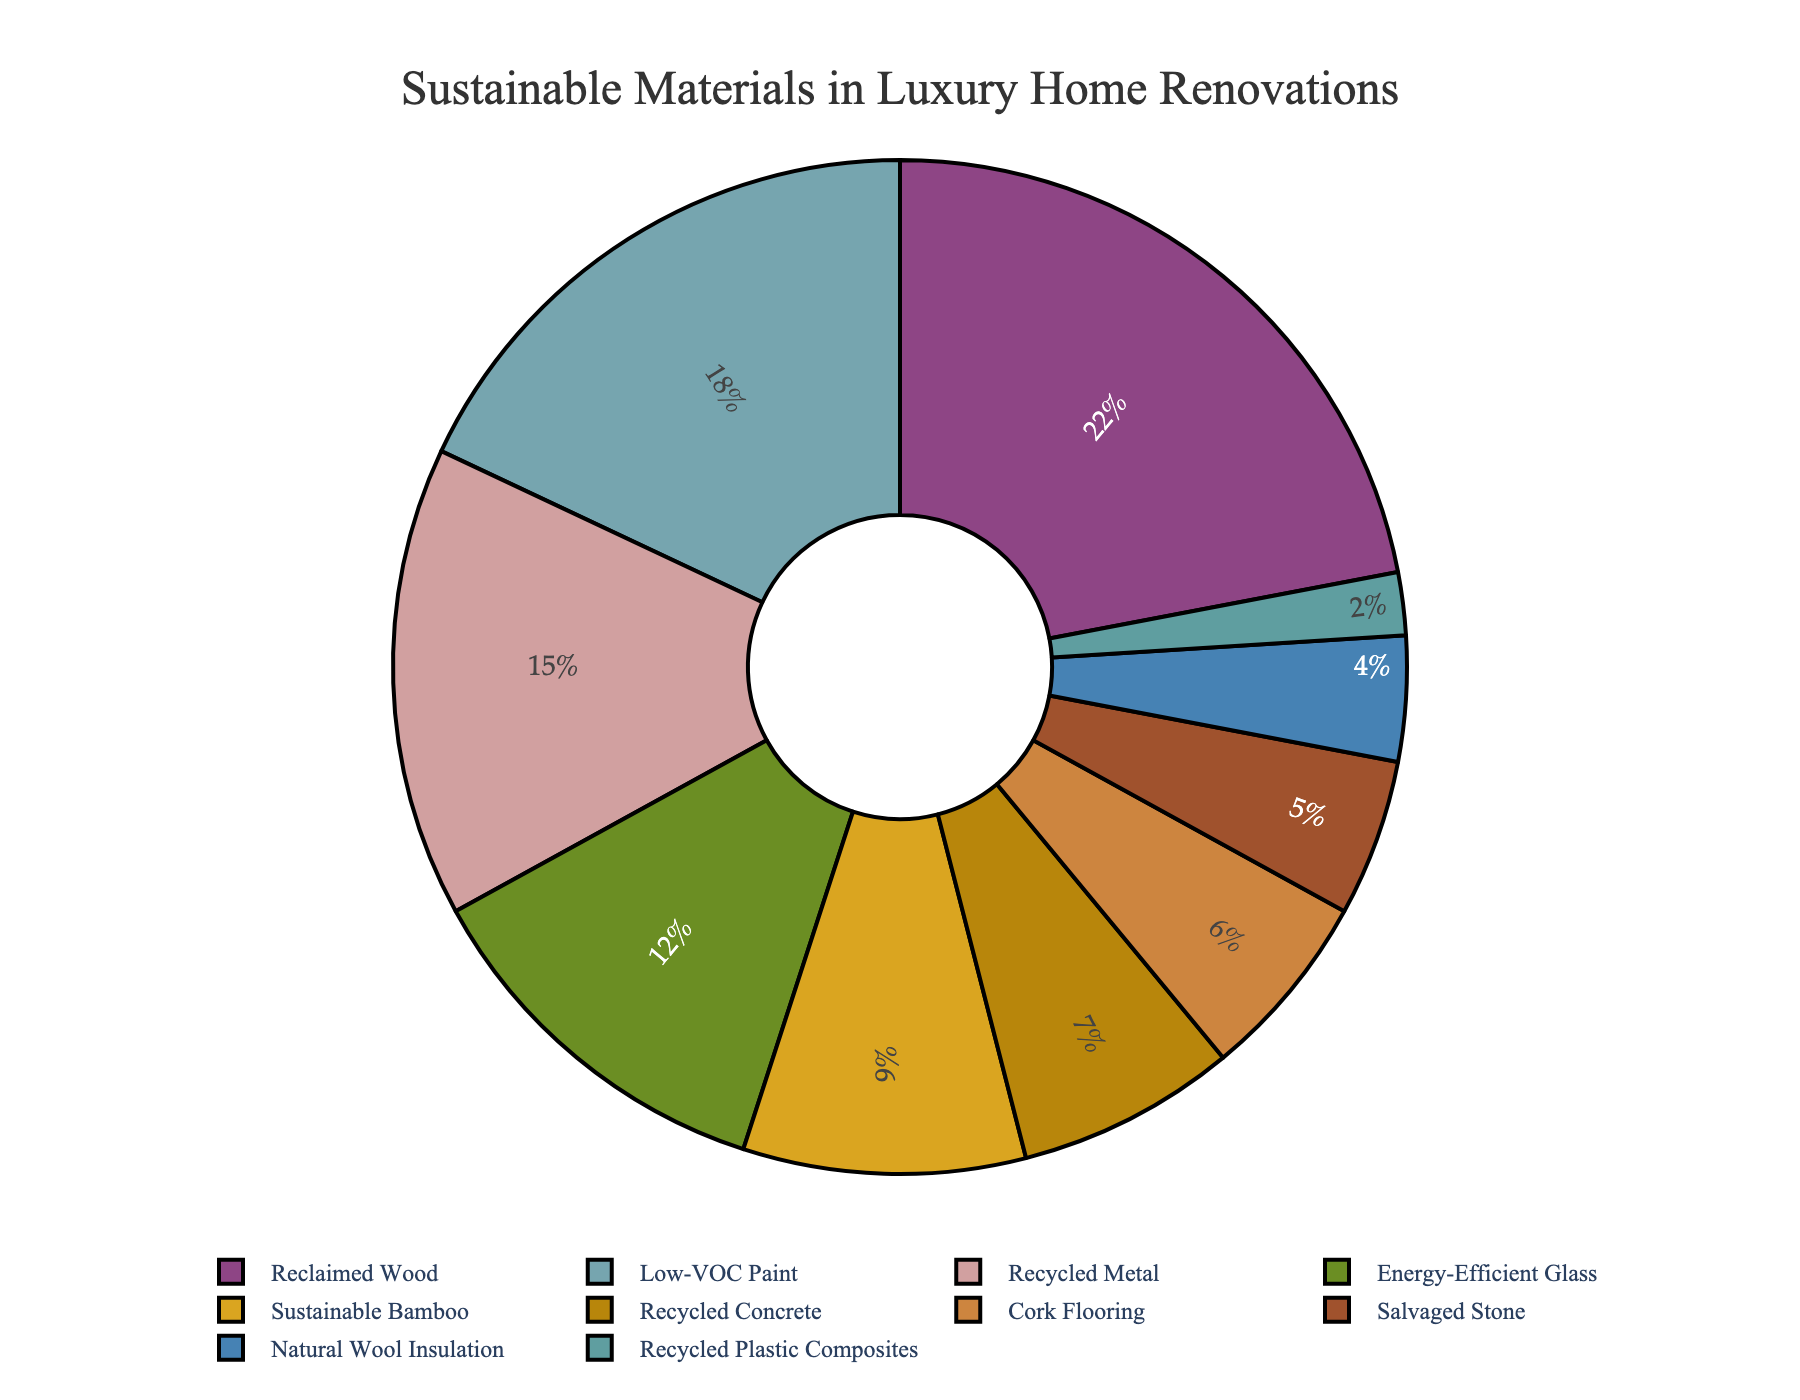What is the largest proportion of sustainable materials used? By looking at the pie chart, we see that the segment for Reclaimed Wood is the largest. It's written as 22%.
Answer: 22% Which material has the smallest proportion? The segment for Recycled Plastic Composites is the smallest, listed as 2%.
Answer: Recycled Plastic Composites What is the combined percentage of Low-VOC Paint and Energy-Efficient Glass? Add the percentages of Low-VOC Paint (18%) and Energy-Efficient Glass (12%), so 18% + 12% = 30%.
Answer: 30% How does the proportion of Recycled Metal compare to Reclaimed Wood? Reclaimed Wood has 22% while Recycled Metal has 15%. Thus, Reclaimed Wood is higher by 22% - 15% = 7%.
Answer: Reclaimed Wood is higher by 7% Which material has a slightly higher percentage than Cork Flooring? Cork Flooring is at 6%, and the next higher percentage is Recycled Concrete at 7%.
Answer: Recycled Concrete What is the difference in percentage between the highest and lowest material proportions? The highest is Reclaimed Wood at 22% and the lowest is Recycled Plastic Composites at 2%. So, 22% - 2% = 20%.
Answer: 20% What percentage of materials used are categorized under metals? Since only Recycled Metal is categorized under metals, it is directly indicated in the pie chart as 15%.
Answer: 15% Which two materials together make up the same percentage as Reclaimed Wood? Reclaimed Wood is 22%. Adding the percentages of Low-VOC Paint (18%) and Recycled Plastic Composites (2%) gives 18% + 2% = 20%, and adding Sustainable Bamboo (9%) and Recycled Concrete (7%) gives 9% + 7% = 16%. Thus, Energy-Efficient Glass (12%) and Low-VOC Paint (18%) combined give 12% + 18% = 30%, which is more. So, finally, it’s the combination of Low-VOC Paint and Recycled Metal which is 18% + 15% = 33%.
Answer: None 